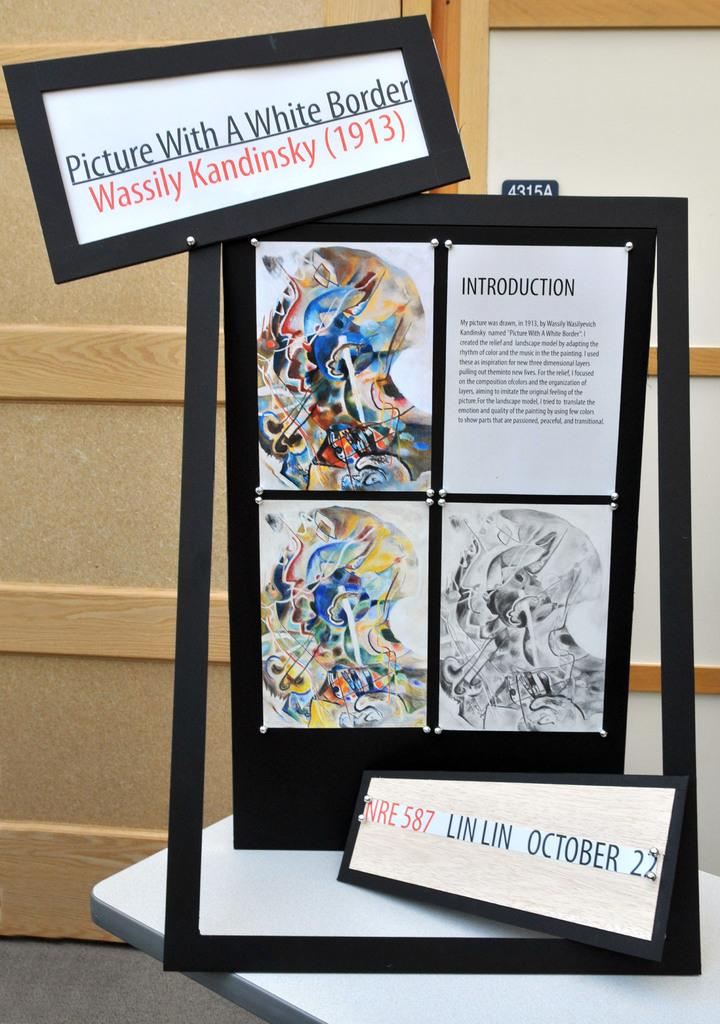<image>
Provide a brief description of the given image. A display that reads, Picture with a white border wassily kandinsky (1913) 